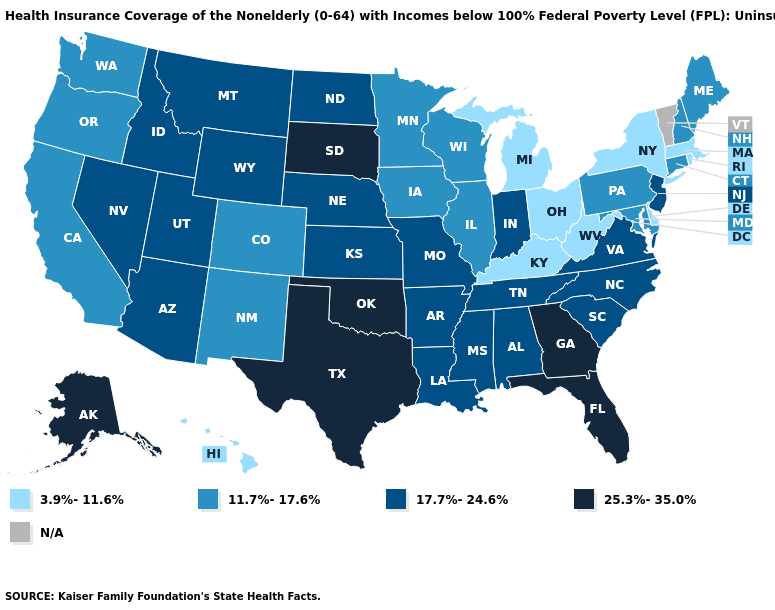What is the highest value in the West ?
Answer briefly. 25.3%-35.0%. Which states hav the highest value in the South?
Keep it brief. Florida, Georgia, Oklahoma, Texas. Does the first symbol in the legend represent the smallest category?
Concise answer only. Yes. Is the legend a continuous bar?
Answer briefly. No. Name the states that have a value in the range N/A?
Concise answer only. Vermont. What is the value of Maryland?
Concise answer only. 11.7%-17.6%. How many symbols are there in the legend?
Short answer required. 5. What is the highest value in the USA?
Answer briefly. 25.3%-35.0%. Name the states that have a value in the range 11.7%-17.6%?
Write a very short answer. California, Colorado, Connecticut, Illinois, Iowa, Maine, Maryland, Minnesota, New Hampshire, New Mexico, Oregon, Pennsylvania, Washington, Wisconsin. What is the value of Oregon?
Keep it brief. 11.7%-17.6%. Which states have the highest value in the USA?
Be succinct. Alaska, Florida, Georgia, Oklahoma, South Dakota, Texas. What is the value of New York?
Be succinct. 3.9%-11.6%. What is the value of Wyoming?
Write a very short answer. 17.7%-24.6%. 